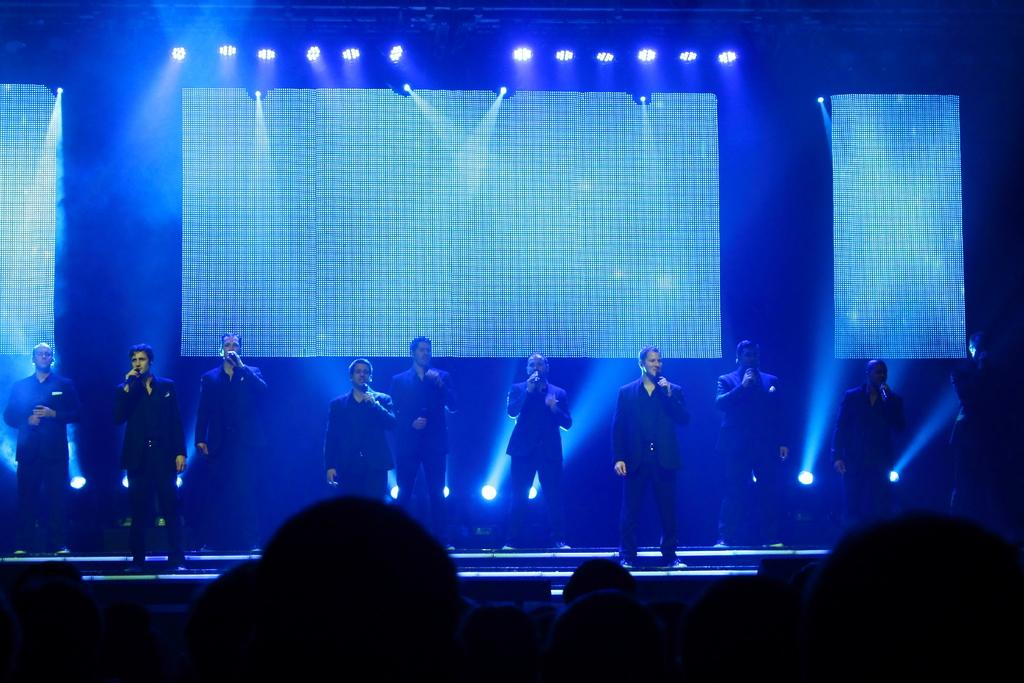How many people are in the image? There is a group of people in the image. Where are some of the people located in the image? Some people are standing on stage. What are the people on stage holding? The people on stage are holding microphones. What can be seen in the background of the image? There are lights visible in the background of the image. Can you see a hole in the stage where the people are standing? There is no hole visible in the stage where the people are standing. 